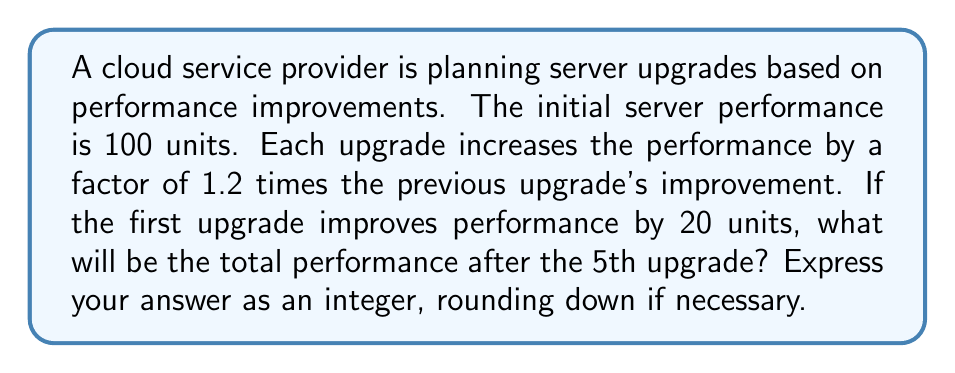Solve this math problem. Let's approach this step-by-step:

1) Initial performance: 100 units

2) First upgrade improvement: 20 units
   Total after 1st upgrade: $100 + 20 = 120$ units

3) For subsequent upgrades, each improvement is 1.2 times the previous:
   2nd upgrade: $20 * 1.2 = 24$ units
   3rd upgrade: $24 * 1.2 = 28.8$ units
   4th upgrade: $28.8 * 1.2 = 34.56$ units
   5th upgrade: $34.56 * 1.2 = 41.472$ units

4) Let's sum up all improvements:
   $20 + 24 + 28.8 + 34.56 + 41.472 = 148.832$ units

5) Total performance after 5th upgrade:
   $100 + 148.832 = 248.832$ units

6) Rounding down to the nearest integer: 248 units
Answer: 248 